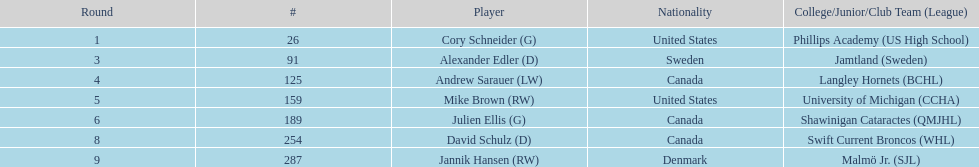What is the number of players originating from the united states? 2. Could you parse the entire table? {'header': ['Round', '#', 'Player', 'Nationality', 'College/Junior/Club Team (League)'], 'rows': [['1', '26', 'Cory Schneider (G)', 'United States', 'Phillips Academy (US High School)'], ['3', '91', 'Alexander Edler (D)', 'Sweden', 'Jamtland (Sweden)'], ['4', '125', 'Andrew Sarauer (LW)', 'Canada', 'Langley Hornets (BCHL)'], ['5', '159', 'Mike Brown (RW)', 'United States', 'University of Michigan (CCHA)'], ['6', '189', 'Julien Ellis (G)', 'Canada', 'Shawinigan Cataractes (QMJHL)'], ['8', '254', 'David Schulz (D)', 'Canada', 'Swift Current Broncos (WHL)'], ['9', '287', 'Jannik Hansen (RW)', 'Denmark', 'Malmö Jr. (SJL)']]} 